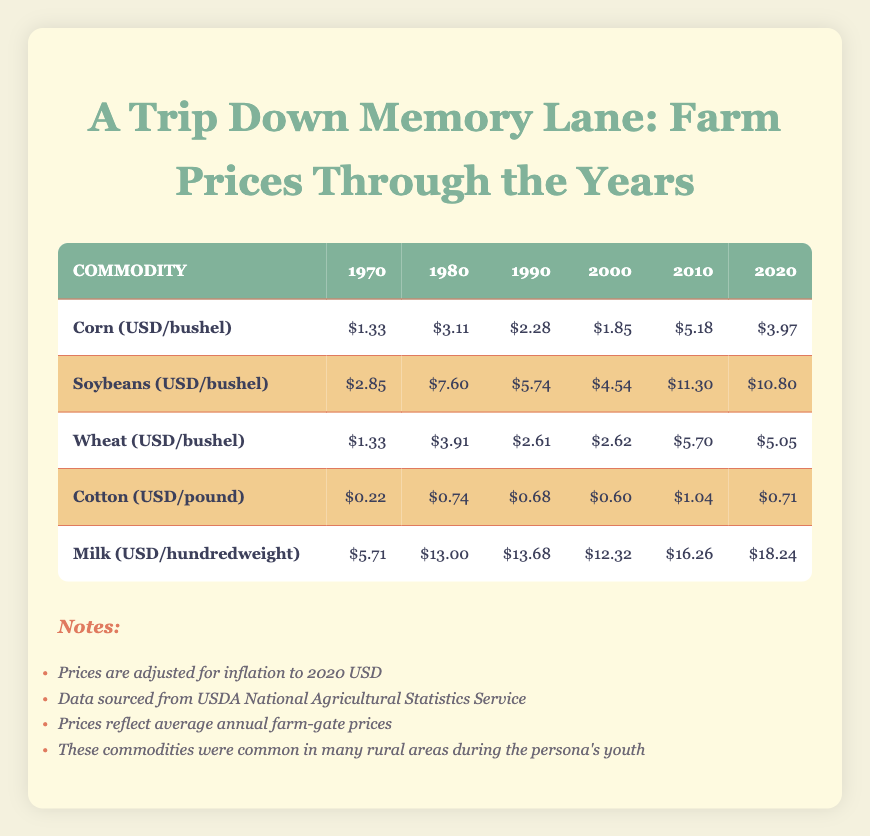What was the price of Corn in 1980? The table shows that the price of Corn in 1980 is listed as $3.11 per bushel.
Answer: $3.11 What was the price of Milk in 2020? According to the table, the price of Milk in 2020 is shown as $18.24 per hundredweight.
Answer: $18.24 Which commodity had the highest price in 2010? Looking at the table for the year 2010, we see Milk at $16.26, Soybeans at $11.30, Corn at $5.18, Wheat at $5.70, and Cotton at $1.04. Therefore, Milk had the highest price.
Answer: Milk What was the average price of Soybeans from 1970 to 2020? To find the average, we sum the prices of Soybeans: (2.85 + 7.60 + 5.74 + 4.54 + 11.30 + 10.80) = 42.83. This total is divided by the number of years, which is 6. Thus, the average price is 42.83 / 6 = 7.14.
Answer: 7.14 Was the price of Cotton higher in 1980 than in 2020? From the table, Cotton was priced at $0.74 in 1980 and $0.71 in 2020. Since $0.74 is greater than $0.71, the statement is true.
Answer: Yes Which commodity had the lowest price in 1970? The prices in 1970 for each commodity were as follows: Corn at $1.33, Soybeans at $2.85, Wheat at $1.33, Cotton at $0.22, and Milk at $5.71. Cotton at $0.22 is the lowest price.
Answer: Cotton What was the overall price trend of Corn from 1970 to 2020? The prices of Corn in 1970 ($1.33), 1980 ($3.11), 1990 ($2.28), 2000 ($1.85), 2010 ($5.18), and 2020 ($3.97) show fluctuations. Initially rising until 1980, then dropping and fluctuating again in future years, but the highest was in 2010. Overall, it was variable.
Answer: Variable trend Is it true that all commodities had a higher price in 2010 compared to 2000? Referencing the table: Corn was $1.85 in 2000 and $5.18 in 2010; Soybeans were $4.54 in 2000 and $11.30 in 2010; Wheat was $2.62 in 2000 and $5.70 in 2010; Cotton was $0.60 in 2000 and $1.04 in 2010; Milk was $12.32 in 2000 and $16.26 in 2010. All commodities showed a price increase from 2000 to 2010, so the statement is true.
Answer: Yes 